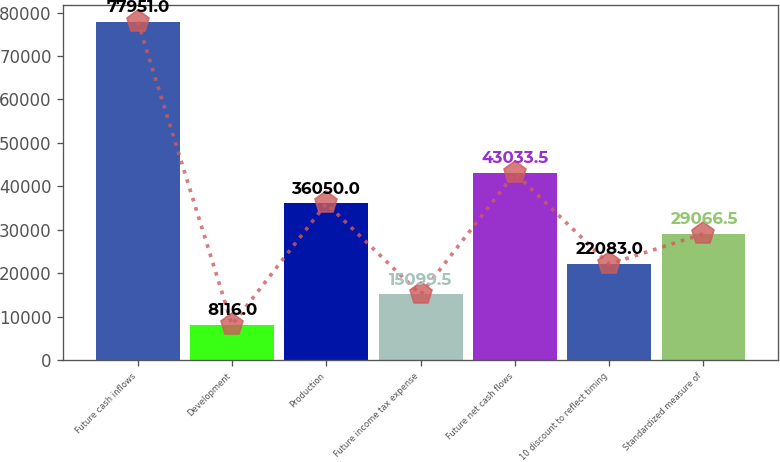Convert chart to OTSL. <chart><loc_0><loc_0><loc_500><loc_500><bar_chart><fcel>Future cash inflows<fcel>Development<fcel>Production<fcel>Future income tax expense<fcel>Future net cash flows<fcel>10 discount to reflect timing<fcel>Standardized measure of<nl><fcel>77951<fcel>8116<fcel>36050<fcel>15099.5<fcel>43033.5<fcel>22083<fcel>29066.5<nl></chart> 